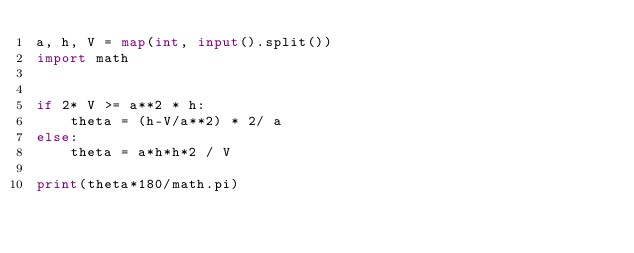Convert code to text. <code><loc_0><loc_0><loc_500><loc_500><_Python_>a, h, V = map(int, input().split())
import math


if 2* V >= a**2 * h:
    theta = (h-V/a**2) * 2/ a
else:
    theta = a*h*h*2 / V

print(theta*180/math.pi)

</code> 